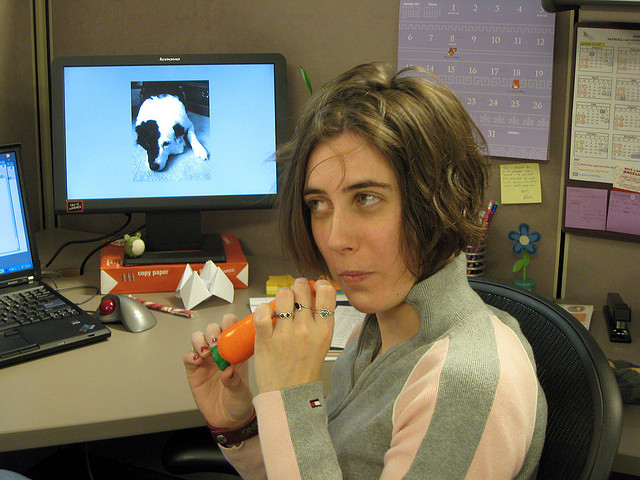Please identify all text content in this image. 25 com 26 31 24 23 12 19 18 17 16 15 14 13 O 11 10 9 B 7 4 4 2 1 